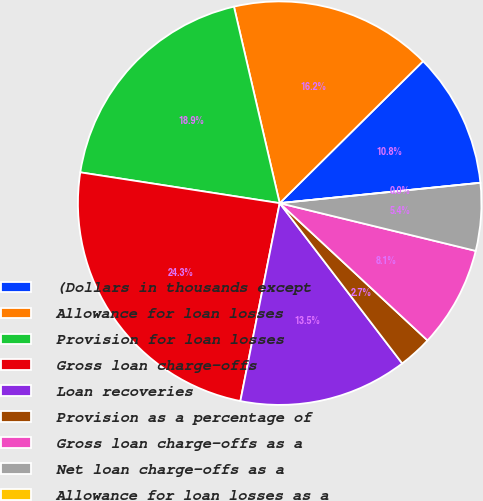Convert chart. <chart><loc_0><loc_0><loc_500><loc_500><pie_chart><fcel>(Dollars in thousands except<fcel>Allowance for loan losses<fcel>Provision for loan losses<fcel>Gross loan charge-offs<fcel>Loan recoveries<fcel>Provision as a percentage of<fcel>Gross loan charge-offs as a<fcel>Net loan charge-offs as a<fcel>Allowance for loan losses as a<nl><fcel>10.81%<fcel>16.22%<fcel>18.92%<fcel>24.32%<fcel>13.51%<fcel>2.7%<fcel>8.11%<fcel>5.41%<fcel>0.0%<nl></chart> 